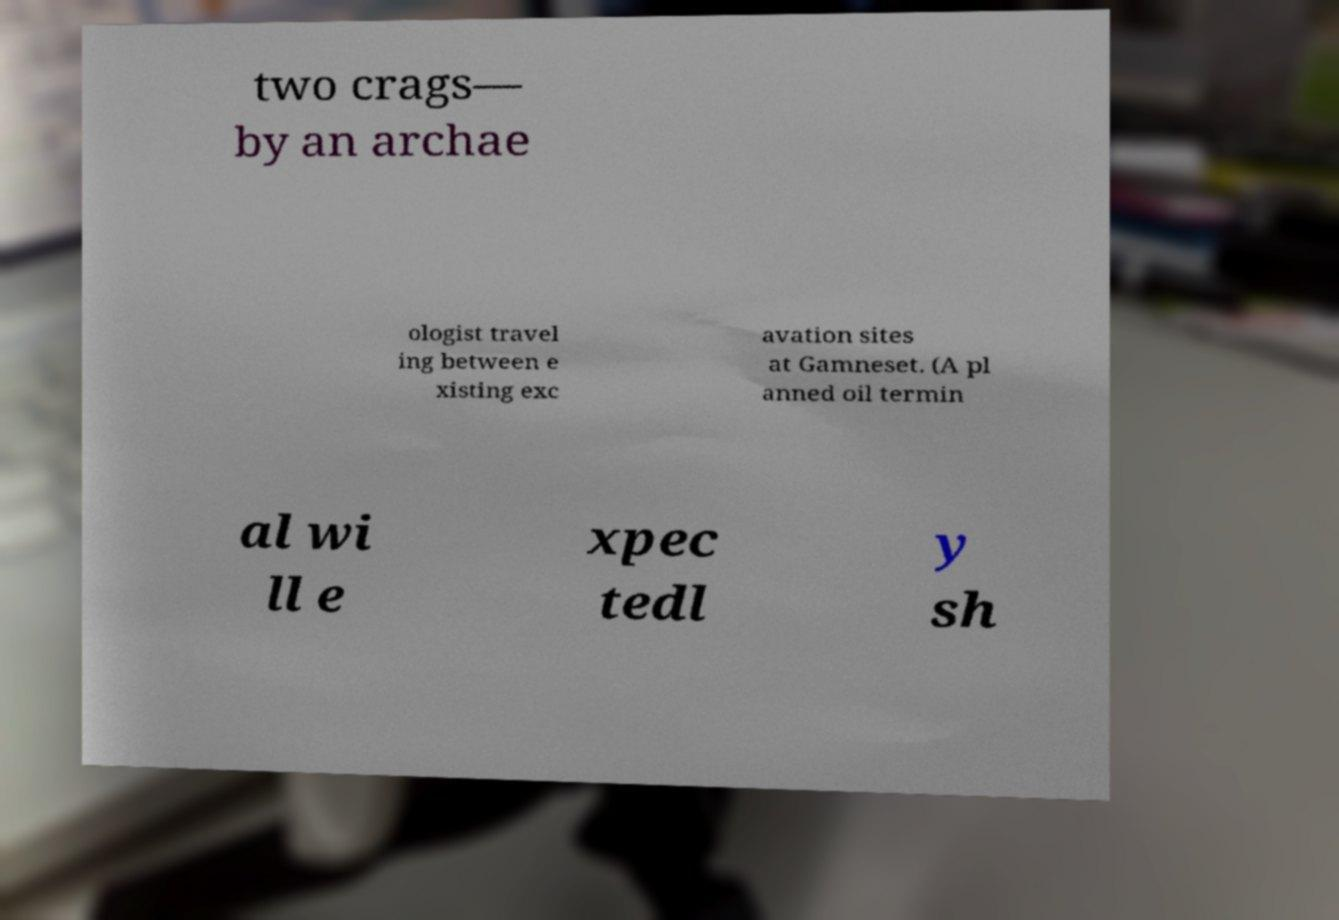For documentation purposes, I need the text within this image transcribed. Could you provide that? two crags— by an archae ologist travel ing between e xisting exc avation sites at Gamneset. (A pl anned oil termin al wi ll e xpec tedl y sh 